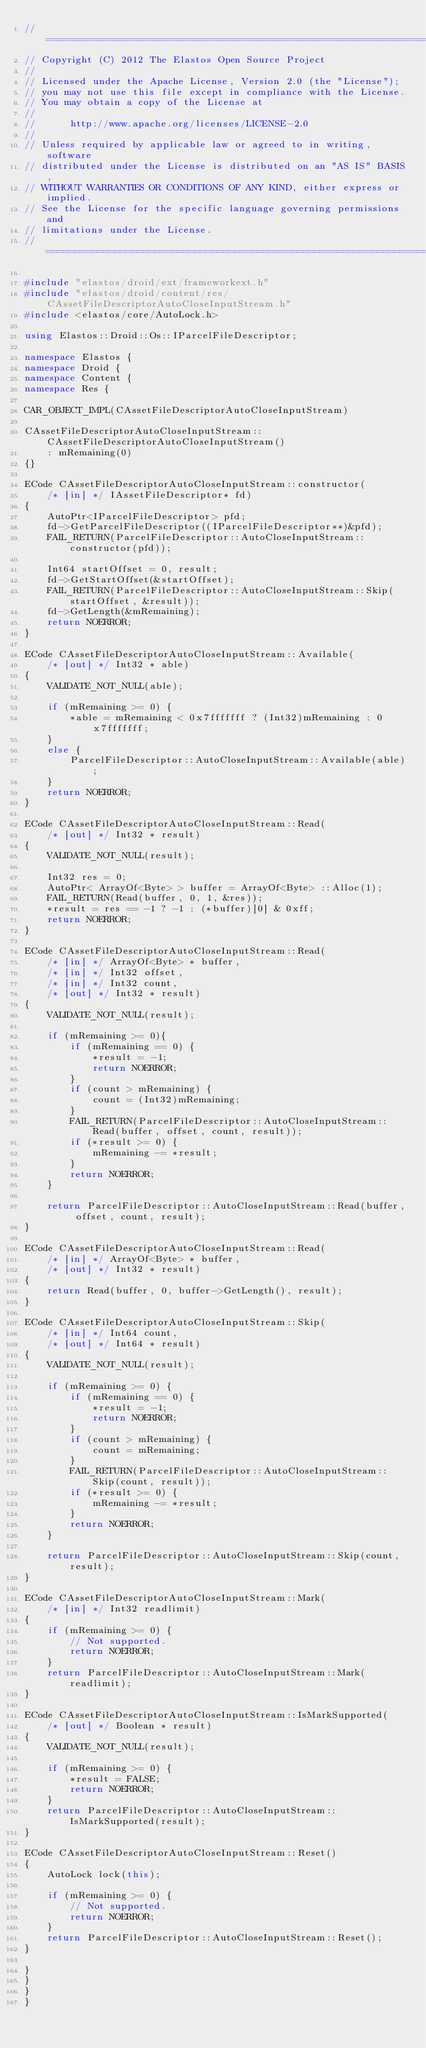Convert code to text. <code><loc_0><loc_0><loc_500><loc_500><_C++_>//=========================================================================
// Copyright (C) 2012 The Elastos Open Source Project
//
// Licensed under the Apache License, Version 2.0 (the "License");
// you may not use this file except in compliance with the License.
// You may obtain a copy of the License at
//
//      http://www.apache.org/licenses/LICENSE-2.0
//
// Unless required by applicable law or agreed to in writing, software
// distributed under the License is distributed on an "AS IS" BASIS,
// WITHOUT WARRANTIES OR CONDITIONS OF ANY KIND, either express or implied.
// See the License for the specific language governing permissions and
// limitations under the License.
//=========================================================================

#include "elastos/droid/ext/frameworkext.h"
#include "elastos/droid/content/res/CAssetFileDescriptorAutoCloseInputStream.h"
#include <elastos/core/AutoLock.h>

using Elastos::Droid::Os::IParcelFileDescriptor;

namespace Elastos {
namespace Droid {
namespace Content {
namespace Res {

CAR_OBJECT_IMPL(CAssetFileDescriptorAutoCloseInputStream)

CAssetFileDescriptorAutoCloseInputStream::CAssetFileDescriptorAutoCloseInputStream()
    : mRemaining(0)
{}

ECode CAssetFileDescriptorAutoCloseInputStream::constructor(
    /* [in] */ IAssetFileDescriptor* fd)
{
    AutoPtr<IParcelFileDescriptor> pfd;
    fd->GetParcelFileDescriptor((IParcelFileDescriptor**)&pfd);
    FAIL_RETURN(ParcelFileDescriptor::AutoCloseInputStream::constructor(pfd));

    Int64 startOffset = 0, result;
    fd->GetStartOffset(&startOffset);
    FAIL_RETURN(ParcelFileDescriptor::AutoCloseInputStream::Skip(startOffset, &result));
    fd->GetLength(&mRemaining);
    return NOERROR;
}

ECode CAssetFileDescriptorAutoCloseInputStream::Available(
    /* [out] */ Int32 * able)
{
    VALIDATE_NOT_NULL(able);

    if (mRemaining >= 0) {
        *able = mRemaining < 0x7fffffff ? (Int32)mRemaining : 0x7fffffff;
    }
    else {
        ParcelFileDescriptor::AutoCloseInputStream::Available(able);
    }
    return NOERROR;
}

ECode CAssetFileDescriptorAutoCloseInputStream::Read(
    /* [out] */ Int32 * result)
{
    VALIDATE_NOT_NULL(result);

    Int32 res = 0;
    AutoPtr< ArrayOf<Byte> > buffer = ArrayOf<Byte> ::Alloc(1);
    FAIL_RETURN(Read(buffer, 0, 1, &res));
    *result = res == -1 ? -1 : (*buffer)[0] & 0xff;
    return NOERROR;
}

ECode CAssetFileDescriptorAutoCloseInputStream::Read(
    /* [in] */ ArrayOf<Byte> * buffer,
    /* [in] */ Int32 offset,
    /* [in] */ Int32 count,
    /* [out] */ Int32 * result)
{
    VALIDATE_NOT_NULL(result);

    if (mRemaining >= 0){
        if (mRemaining == 0) {
            *result = -1;
            return NOERROR;
        }
        if (count > mRemaining) {
            count = (Int32)mRemaining;
        }
        FAIL_RETURN(ParcelFileDescriptor::AutoCloseInputStream::Read(buffer, offset, count, result));
        if (*result >= 0) {
            mRemaining -= *result;
        }
        return NOERROR;
    }

    return ParcelFileDescriptor::AutoCloseInputStream::Read(buffer, offset, count, result);
}

ECode CAssetFileDescriptorAutoCloseInputStream::Read(
    /* [in] */ ArrayOf<Byte> * buffer,
    /* [out] */ Int32 * result)
{
    return Read(buffer, 0, buffer->GetLength(), result);
}

ECode CAssetFileDescriptorAutoCloseInputStream::Skip(
    /* [in] */ Int64 count,
    /* [out] */ Int64 * result)
{
    VALIDATE_NOT_NULL(result);

    if (mRemaining >= 0) {
        if (mRemaining == 0) {
            *result = -1;
            return NOERROR;
        }
        if (count > mRemaining) {
            count = mRemaining;
        }
        FAIL_RETURN(ParcelFileDescriptor::AutoCloseInputStream::Skip(count, result));
        if (*result >= 0) {
            mRemaining -= *result;
        }
        return NOERROR;
    }

    return ParcelFileDescriptor::AutoCloseInputStream::Skip(count, result);
}

ECode CAssetFileDescriptorAutoCloseInputStream::Mark(
    /* [in] */ Int32 readlimit)
{
    if (mRemaining >= 0) {
        // Not supported.
        return NOERROR;
    }
    return ParcelFileDescriptor::AutoCloseInputStream::Mark(readlimit);
}

ECode CAssetFileDescriptorAutoCloseInputStream::IsMarkSupported(
    /* [out] */ Boolean * result)
{
    VALIDATE_NOT_NULL(result);

    if (mRemaining >= 0) {
        *result = FALSE;
        return NOERROR;
    }
    return ParcelFileDescriptor::AutoCloseInputStream::IsMarkSupported(result);
}

ECode CAssetFileDescriptorAutoCloseInputStream::Reset()
{
    AutoLock lock(this);

    if (mRemaining >= 0) {
        // Not supported.
        return NOERROR;
    }
    return ParcelFileDescriptor::AutoCloseInputStream::Reset();
}

}
}
}
}
</code> 